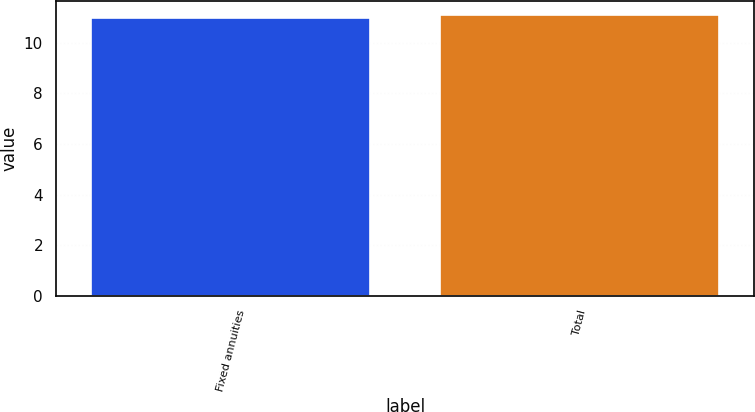<chart> <loc_0><loc_0><loc_500><loc_500><bar_chart><fcel>Fixed annuities<fcel>Total<nl><fcel>11<fcel>11.1<nl></chart> 